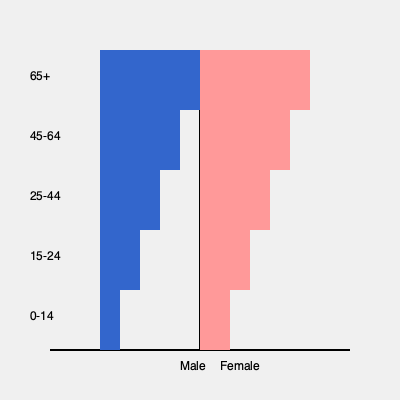Based on the population pyramid shown, which demographic trend is most likely to impact the consumer market in Sri Lanka over the next decade, and how might this affect product strategies for a conglomerate operating in the country? To answer this question, let's analyze the population pyramid step-by-step:

1. Shape analysis: The pyramid has a narrow base and a wider middle, indicating an aging population.

2. Age distribution:
   - The 0-14 and 15-24 age groups are smaller than the middle-age groups.
   - The largest groups are in the 25-44 and 45-64 age ranges.
   - There's a significant population in the 65+ age group.

3. Gender distribution: The female population is slightly larger than the male population across all age groups.

4. Demographic trend: The most significant trend is the aging population, as evidenced by the larger middle and upper sections of the pyramid.

5. Impact on consumer market:
   - Increasing demand for products and services catering to older adults.
   - Potential decrease in demand for youth-oriented products.
   - Growing market for healthcare and wellness products.

6. Product strategy implications:
   - Develop products that cater to the needs of older consumers (e.g., easy-to-use technology, health supplements).
   - Focus on premium products for the large middle-aged population with higher disposable income.
   - Invest in healthcare-related businesses or partnerships.
   - Adapt marketing strategies to appeal to older demographics.
   - Consider products that support multigenerational households.

The aging population trend will likely have the most significant impact on the consumer market in Sri Lanka over the next decade. Conglomerates should adjust their product strategies to cater to the needs and preferences of older consumers while maintaining offerings for the still substantial younger population.
Answer: Aging population; shift focus to products/services for older consumers and healthcare market. 